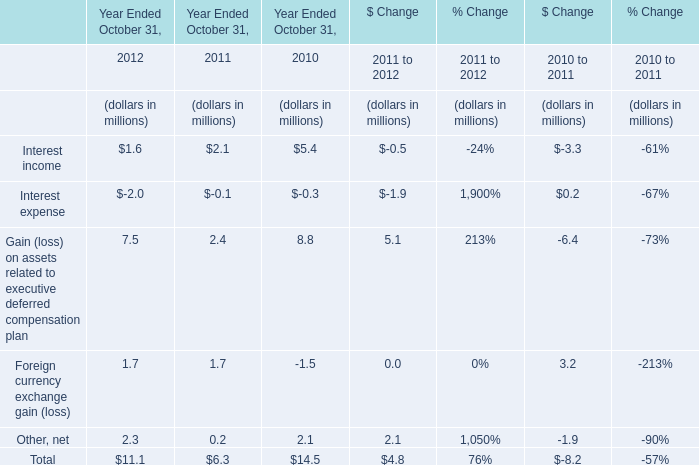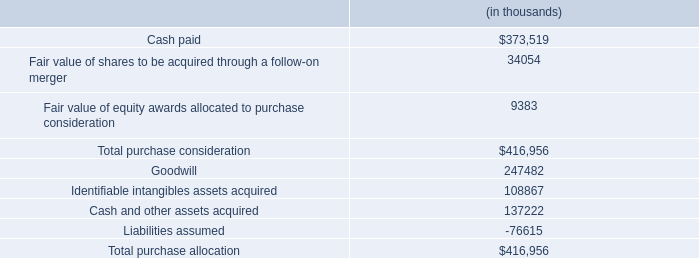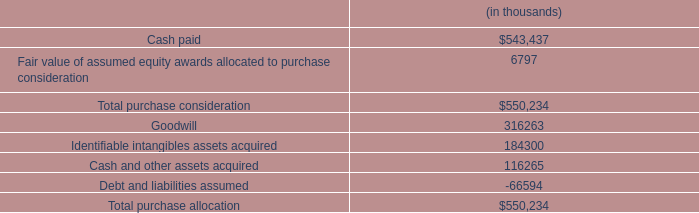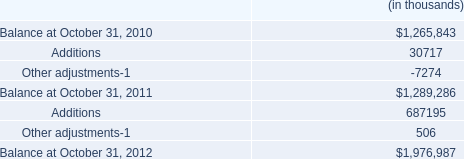what percentage of the total purchase consideration is comprised of goodwill and identifiable intangibles assets acquired? 
Computations: ((247482 + 108867) / 416956)
Answer: 0.85464. 